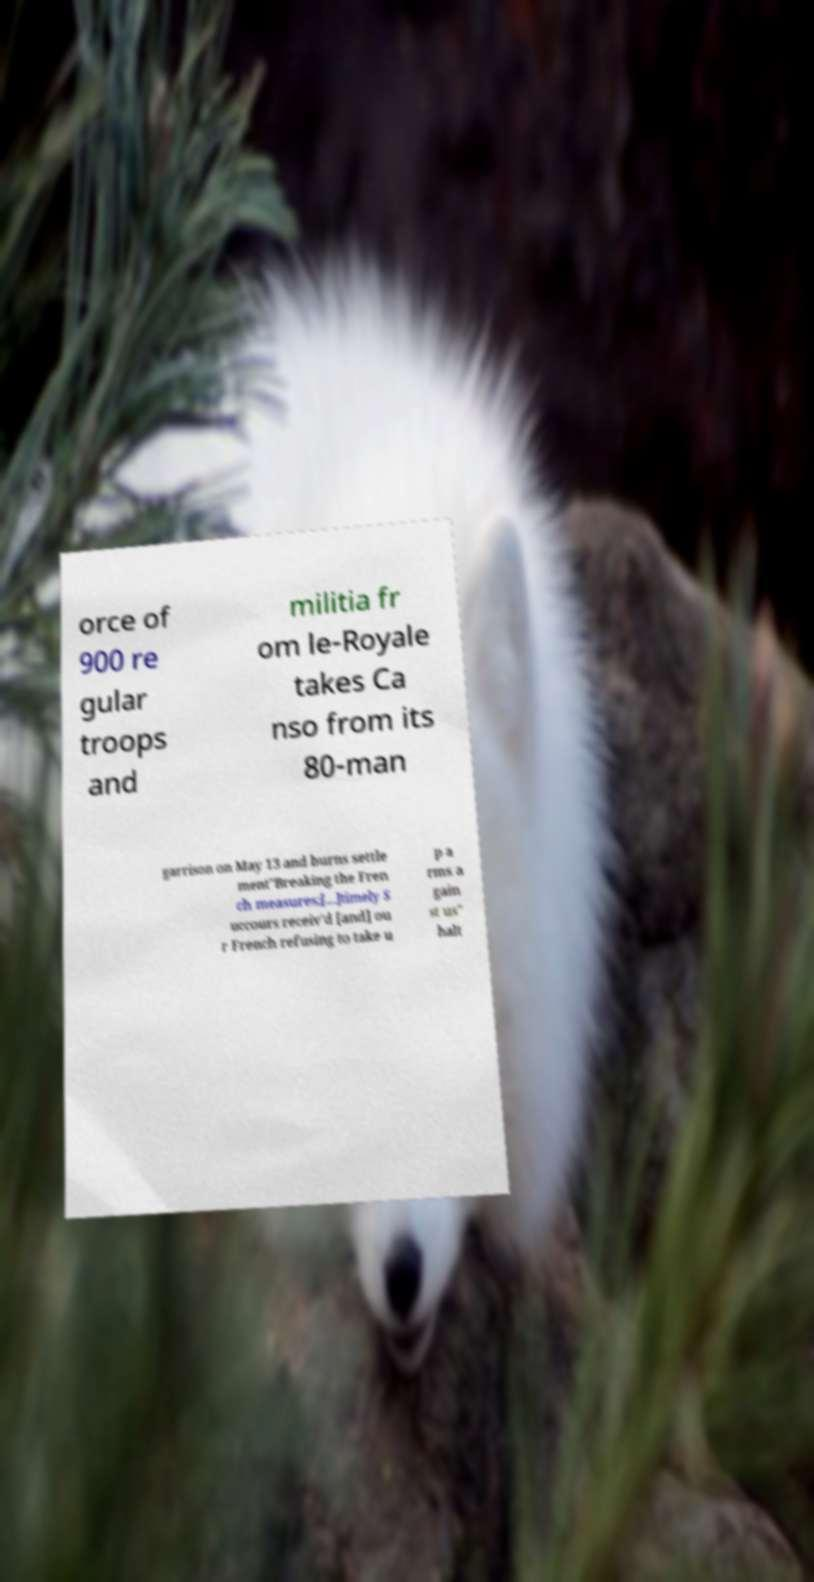I need the written content from this picture converted into text. Can you do that? orce of 900 re gular troops and militia fr om le-Royale takes Ca nso from its 80-man garrison on May 13 and burns settle ment"Breaking the Fren ch measures;[...]timely S uccours receiv'd [and] ou r French refusing to take u p a rms a gain st us" halt 